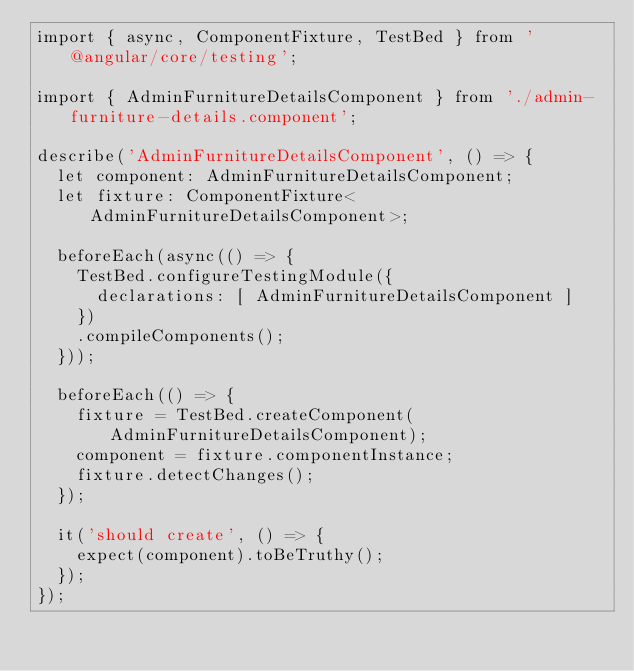<code> <loc_0><loc_0><loc_500><loc_500><_TypeScript_>import { async, ComponentFixture, TestBed } from '@angular/core/testing';

import { AdminFurnitureDetailsComponent } from './admin-furniture-details.component';

describe('AdminFurnitureDetailsComponent', () => {
  let component: AdminFurnitureDetailsComponent;
  let fixture: ComponentFixture<AdminFurnitureDetailsComponent>;

  beforeEach(async(() => {
    TestBed.configureTestingModule({
      declarations: [ AdminFurnitureDetailsComponent ]
    })
    .compileComponents();
  }));

  beforeEach(() => {
    fixture = TestBed.createComponent(AdminFurnitureDetailsComponent);
    component = fixture.componentInstance;
    fixture.detectChanges();
  });

  it('should create', () => {
    expect(component).toBeTruthy();
  });
});
</code> 